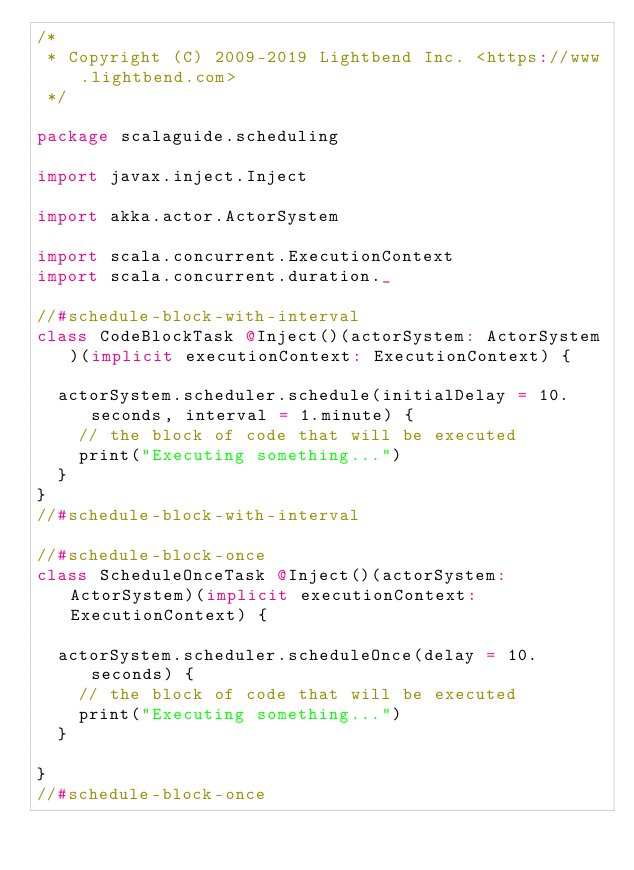<code> <loc_0><loc_0><loc_500><loc_500><_Scala_>/*
 * Copyright (C) 2009-2019 Lightbend Inc. <https://www.lightbend.com>
 */

package scalaguide.scheduling

import javax.inject.Inject

import akka.actor.ActorSystem

import scala.concurrent.ExecutionContext
import scala.concurrent.duration._

//#schedule-block-with-interval
class CodeBlockTask @Inject()(actorSystem: ActorSystem)(implicit executionContext: ExecutionContext) {

  actorSystem.scheduler.schedule(initialDelay = 10.seconds, interval = 1.minute) {
    // the block of code that will be executed
    print("Executing something...")
  }
}
//#schedule-block-with-interval

//#schedule-block-once
class ScheduleOnceTask @Inject()(actorSystem: ActorSystem)(implicit executionContext: ExecutionContext) {

  actorSystem.scheduler.scheduleOnce(delay = 10.seconds) {
    // the block of code that will be executed
    print("Executing something...")
  }

}
//#schedule-block-once
</code> 